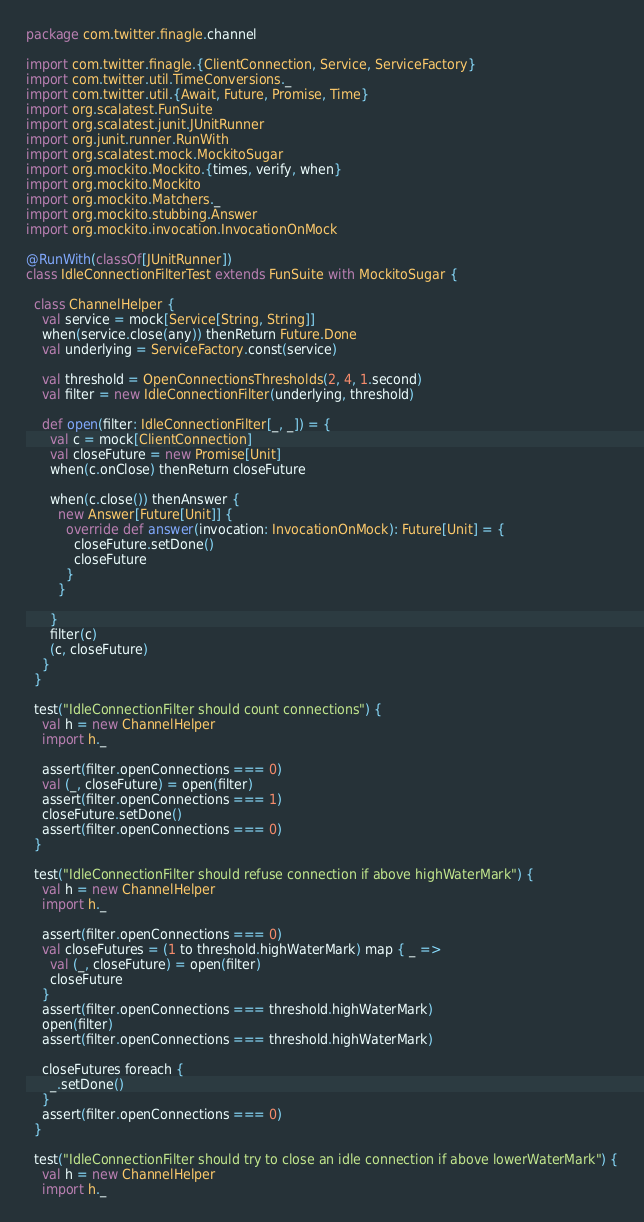<code> <loc_0><loc_0><loc_500><loc_500><_Scala_>package com.twitter.finagle.channel

import com.twitter.finagle.{ClientConnection, Service, ServiceFactory}
import com.twitter.util.TimeConversions._
import com.twitter.util.{Await, Future, Promise, Time}
import org.scalatest.FunSuite
import org.scalatest.junit.JUnitRunner
import org.junit.runner.RunWith
import org.scalatest.mock.MockitoSugar
import org.mockito.Mockito.{times, verify, when}
import org.mockito.Mockito
import org.mockito.Matchers._
import org.mockito.stubbing.Answer
import org.mockito.invocation.InvocationOnMock

@RunWith(classOf[JUnitRunner])
class IdleConnectionFilterTest extends FunSuite with MockitoSugar {

  class ChannelHelper {
    val service = mock[Service[String, String]]
    when(service.close(any)) thenReturn Future.Done
    val underlying = ServiceFactory.const(service)

    val threshold = OpenConnectionsThresholds(2, 4, 1.second)
    val filter = new IdleConnectionFilter(underlying, threshold)

    def open(filter: IdleConnectionFilter[_, _]) = {
      val c = mock[ClientConnection]
      val closeFuture = new Promise[Unit]
      when(c.onClose) thenReturn closeFuture

      when(c.close()) thenAnswer {
        new Answer[Future[Unit]] {
          override def answer(invocation: InvocationOnMock): Future[Unit] = {
            closeFuture.setDone()
            closeFuture
          }
        }

      }
      filter(c)
      (c, closeFuture)
    }
  }

  test("IdleConnectionFilter should count connections") {
    val h = new ChannelHelper
    import h._

    assert(filter.openConnections === 0)
    val (_, closeFuture) = open(filter)
    assert(filter.openConnections === 1)
    closeFuture.setDone()
    assert(filter.openConnections === 0)
  }

  test("IdleConnectionFilter should refuse connection if above highWaterMark") {
    val h = new ChannelHelper
    import h._

    assert(filter.openConnections === 0)
    val closeFutures = (1 to threshold.highWaterMark) map { _ =>
      val (_, closeFuture) = open(filter)
      closeFuture
    }
    assert(filter.openConnections === threshold.highWaterMark)
    open(filter)
    assert(filter.openConnections === threshold.highWaterMark)

    closeFutures foreach {
      _.setDone()
    }
    assert(filter.openConnections === 0)
  }

  test("IdleConnectionFilter should try to close an idle connection if above lowerWaterMark") {
    val h = new ChannelHelper
    import h._
</code> 